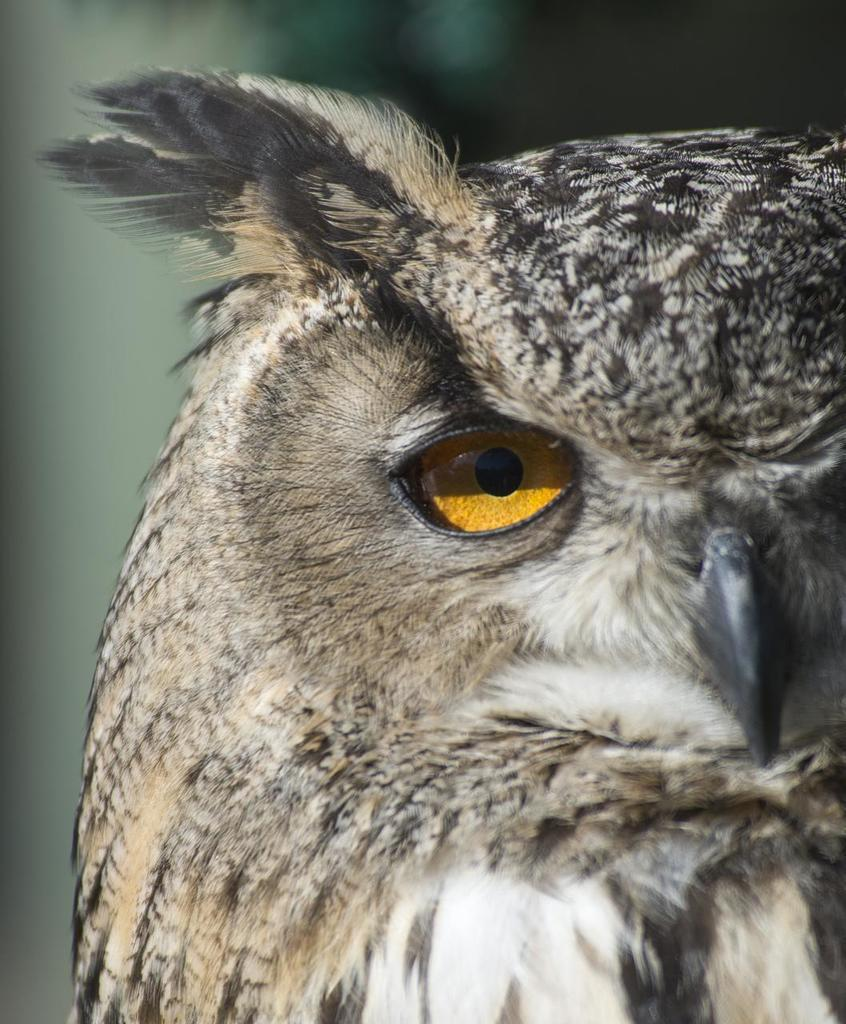What type of animal is in the image? There is an owl in the image. What colors can be seen on the owl? The owl is in brown and black colors. What color is the background of the image? The background of the image is green. How many chairs are visible in the image? There are no chairs present in the image; it features an owl in a green background. 